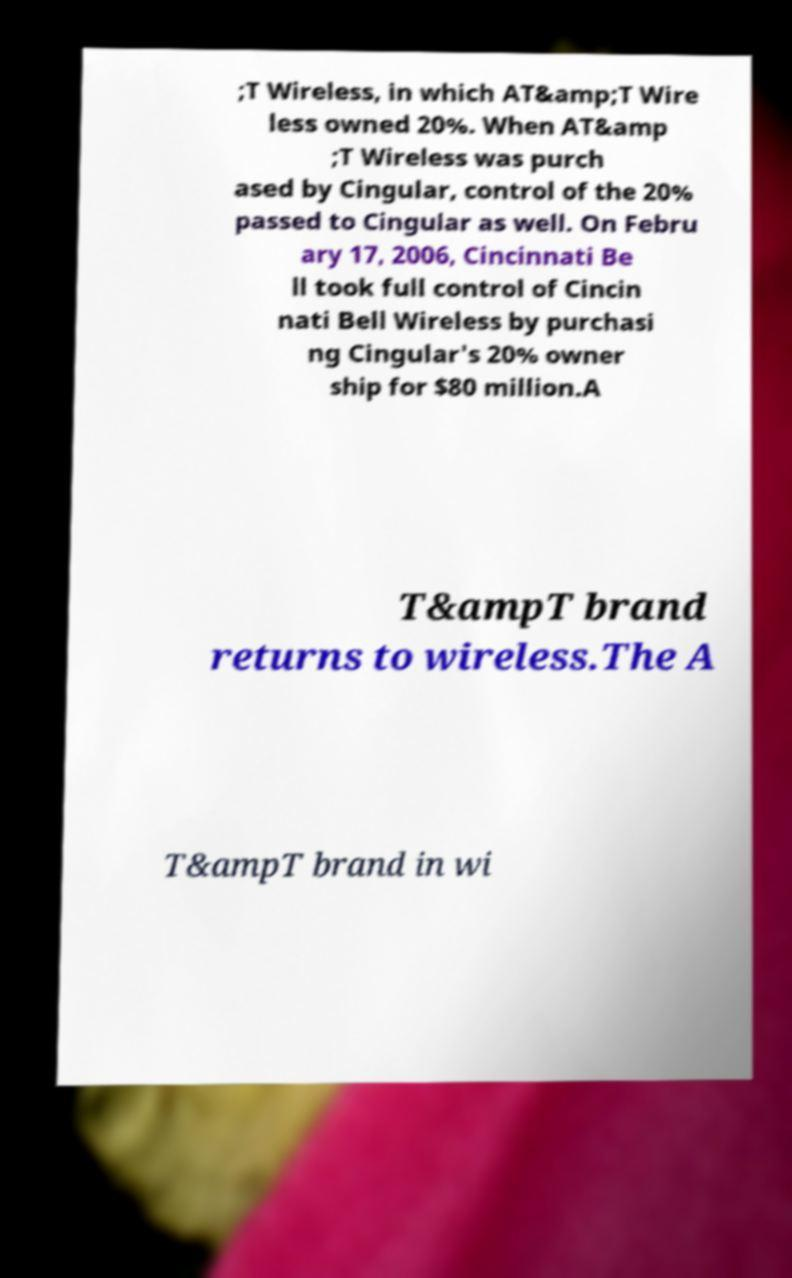What messages or text are displayed in this image? I need them in a readable, typed format. ;T Wireless, in which AT&amp;T Wire less owned 20%. When AT&amp ;T Wireless was purch ased by Cingular, control of the 20% passed to Cingular as well. On Febru ary 17, 2006, Cincinnati Be ll took full control of Cincin nati Bell Wireless by purchasi ng Cingular's 20% owner ship for $80 million.A T&ampT brand returns to wireless.The A T&ampT brand in wi 